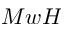Convert formula to latex. <formula><loc_0><loc_0><loc_500><loc_500>M w H</formula> 